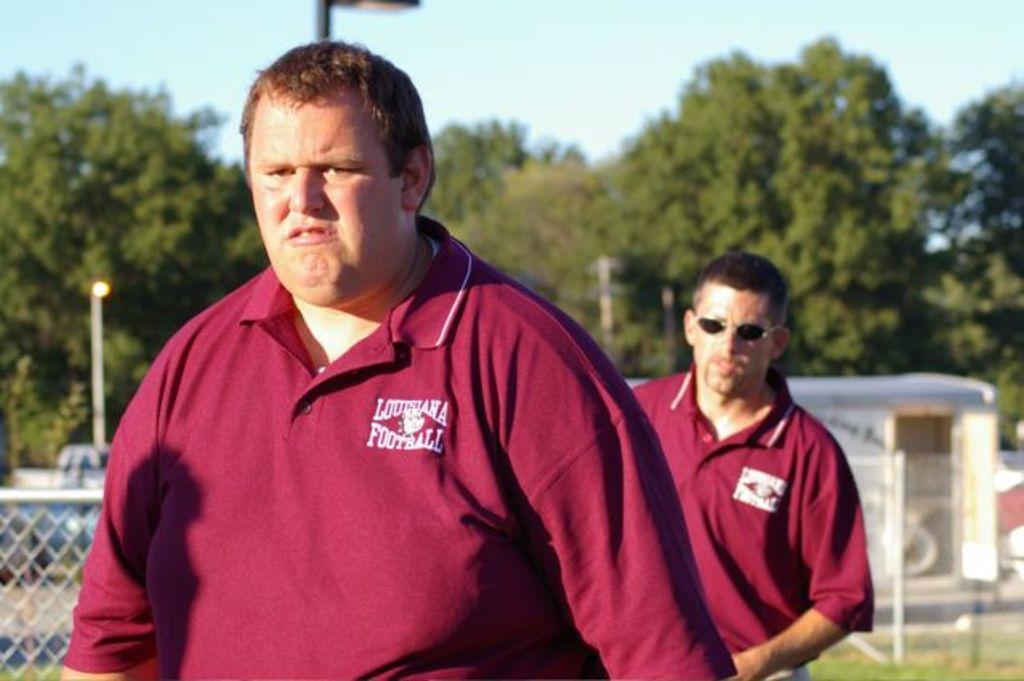What state do these men live in?
Keep it short and to the point. Louisiana. 